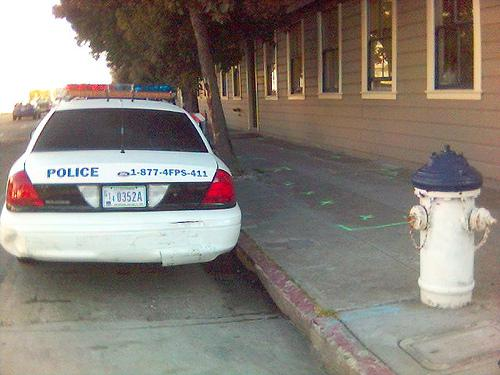Question: how many windows are pictured?
Choices:
A. Seven.
B. One.
C. Two.
D. Three.
Answer with the letter. Answer: A Question: what kind of car is pictured?
Choices:
A. A truck.
B. Police car.
C. A convertible.
D. A motorcycle.
Answer with the letter. Answer: B Question: who would drive the car?
Choices:
A. A fireman.
B. A conducter.
C. Policeman.
D. A race car driver.
Answer with the letter. Answer: C 